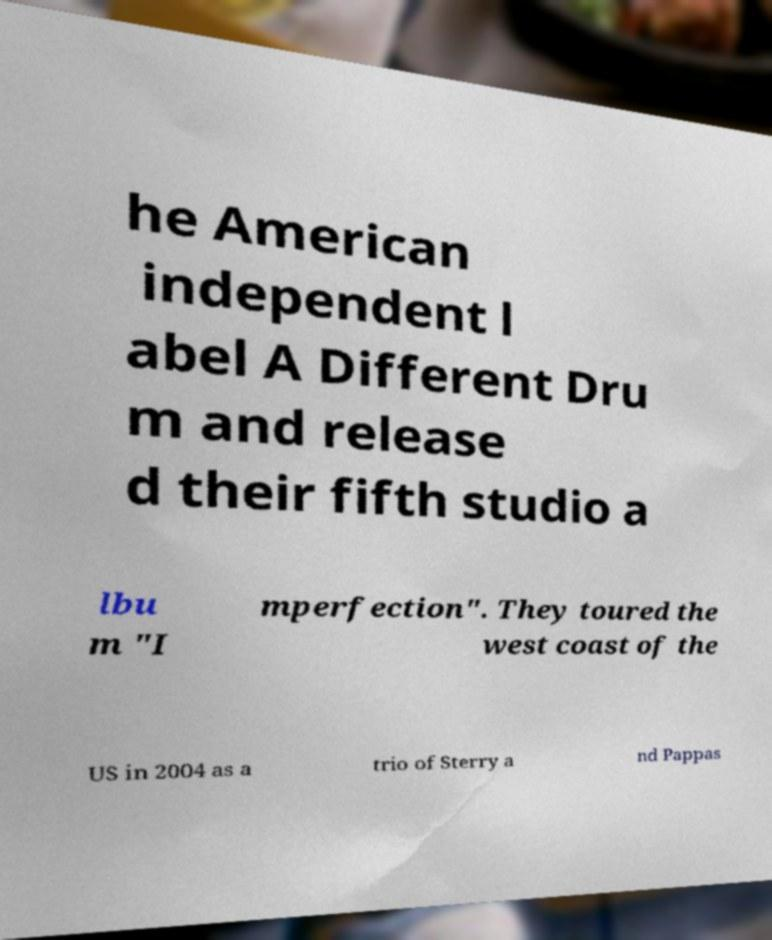There's text embedded in this image that I need extracted. Can you transcribe it verbatim? he American independent l abel A Different Dru m and release d their fifth studio a lbu m "I mperfection". They toured the west coast of the US in 2004 as a trio of Sterry a nd Pappas 